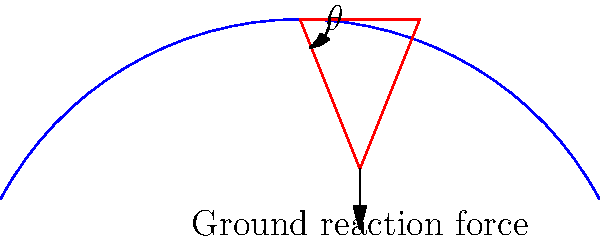During a hike on Villapuram's hilly terrain, you encounter a steep incline. The angle between your leg and the ground is $\theta = 70^\circ$. If your body weight is 700 N and you're standing still, what is the magnitude of the ground reaction force acting on your foot? To solve this problem, we'll follow these steps:

1) In static equilibrium, the sum of all forces must be zero. The forces acting on the hiker are:
   - Weight (W) acting downward
   - Ground reaction force (GRF) perpendicular to the slope
   - Friction force parallel to the slope (which we'll ignore for this calculation)

2) We need to find the component of the weight that's perpendicular to the slope, as this will be equal and opposite to the GRF.

3) The angle between the leg and the ground is $70^\circ$, so the angle between the leg and the vertical is $20^\circ$ (as $90^\circ - 70^\circ = 20^\circ$).

4) The component of the weight perpendicular to the slope is:

   $GRF = W \cos(20^\circ)$

5) Plugging in the values:

   $GRF = 700 \text{ N} \times \cos(20^\circ)$

6) Using a calculator or trigonometric tables:

   $GRF = 700 \text{ N} \times 0.9397 = 657.79 \text{ N}$

Therefore, the magnitude of the ground reaction force is approximately 658 N.
Answer: 658 N 